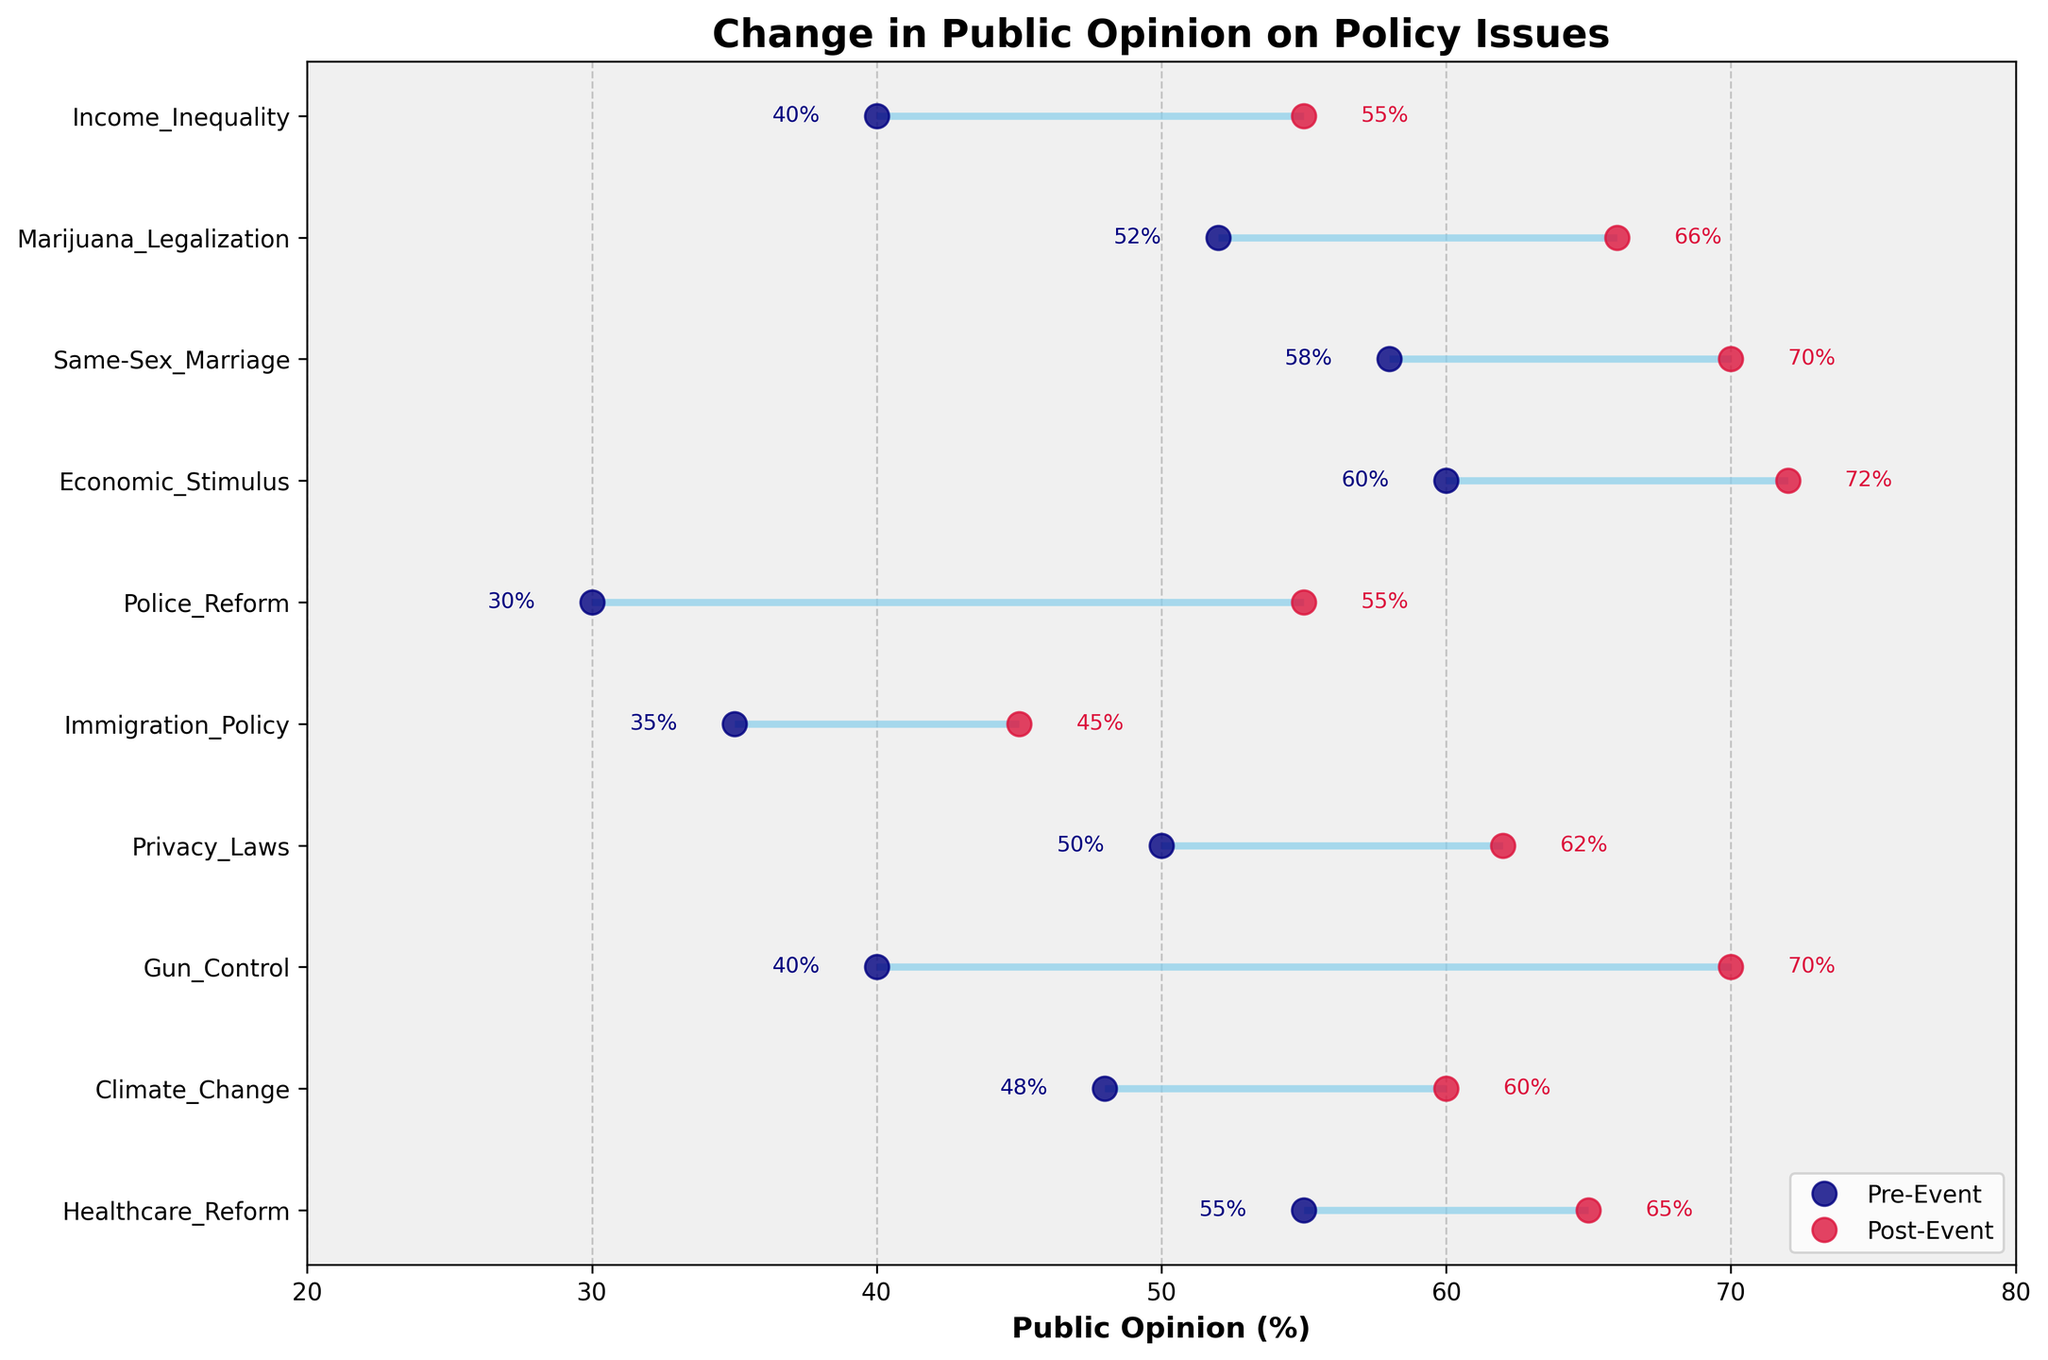What is the title of the plot? The title is displayed at the top of the plot.
Answer: Change in Public Opinion on Policy Issues What colors are used to represent Pre-Event and Post-Event opinions? Pre-Event opinions are represented by navy dots, and Post-Event opinions are represented by crimson dots.
Answer: Navy and crimson How many policy issues are compared in the plot? The y-axis has ticks corresponding to each policy issue, so counting these will give the number of policy issues.
Answer: 10 Which policy issue saw the largest increase in public opinion after the event? By examining the lengths of the lines between pre and post-event opinions, the longest line indicates the largest increase. Gun_Control shows the largest increase from 40% to 70%.
Answer: Gun_Control What is the public opinion on Police Reform after George Floyd Protests? Locate the data point for Police Reform on the y-axis and read the corresponding Post-Event opinion on the x-axis.
Answer: 55% Which policy issue had a higher public opinion before the event: Climate_Change or Same-Sex_Marriage? Compare the Pre-Event values for both issues. Climate_Change had 48% and Same-Sex_Marriage had 58%.
Answer: Same-Sex_Marriage What is the average public opinion for pre-event data across all policy issues? Sum all the pre-event percentages and divide by the number of policy issues (10). (55+48+40+50+35+30+60+58+52+40)/10 = 46.8
Answer: 46.8% How did public opinion change on Privacy Laws after the Facebook Data Scandal? Calculate the difference between Pre-Event and Post-Event opinions for Privacy Laws. (62% - 50%) = 12% increase
Answer: 12% increase After which event did public opinion on Immigration Policy change? Locate Immigration Policy on the y-axis and see the corresponding event on the y-axis label.
Answer: Trump Immigration Ban 